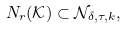Convert formula to latex. <formula><loc_0><loc_0><loc_500><loc_500>N _ { r } ( \mathcal { K } ) \subset \mathcal { N } _ { \delta , \tau , k } ,</formula> 